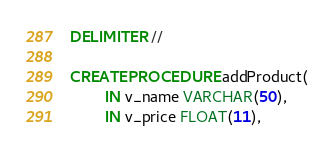Convert code to text. <code><loc_0><loc_0><loc_500><loc_500><_SQL_>DELIMITER //

CREATE PROCEDURE addProduct(
		IN v_name VARCHAR(50), 
        IN v_price FLOAT(11),</code> 